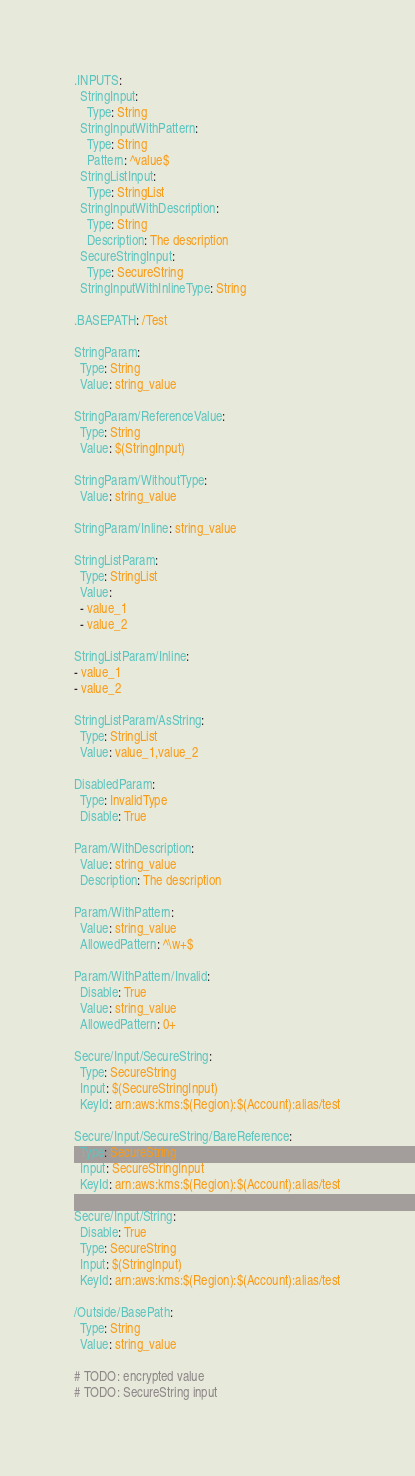Convert code to text. <code><loc_0><loc_0><loc_500><loc_500><_YAML_>.INPUTS:
  StringInput:
    Type: String
  StringInputWithPattern:
    Type: String
    Pattern: ^value$
  StringListInput:
    Type: StringList
  StringInputWithDescription:
    Type: String
    Description: The description
  SecureStringInput:
    Type: SecureString
  StringInputWithInlineType: String

.BASEPATH: /Test

StringParam:
  Type: String
  Value: string_value

StringParam/ReferenceValue:
  Type: String
  Value: $(StringInput)

StringParam/WithoutType:
  Value: string_value

StringParam/Inline: string_value

StringListParam:
  Type: StringList
  Value:
  - value_1
  - value_2

StringListParam/Inline:
- value_1
- value_2

StringListParam/AsString:
  Type: StringList
  Value: value_1,value_2

DisabledParam:
  Type: InvalidType
  Disable: True

Param/WithDescription:
  Value: string_value
  Description: The description

Param/WithPattern:
  Value: string_value
  AllowedPattern: ^\w+$

Param/WithPattern/Invalid:
  Disable: True
  Value: string_value
  AllowedPattern: 0+

Secure/Input/SecureString:
  Type: SecureString
  Input: $(SecureStringInput)
  KeyId: arn:aws:kms:$(Region):$(Account):alias/test

Secure/Input/SecureString/BareReference:
  Type: SecureString
  Input: SecureStringInput
  KeyId: arn:aws:kms:$(Region):$(Account):alias/test

Secure/Input/String:
  Disable: True
  Type: SecureString
  Input: $(StringInput)
  KeyId: arn:aws:kms:$(Region):$(Account):alias/test

/Outside/BasePath:
  Type: String
  Value: string_value

# TODO: encrypted value
# TODO: SecureString input</code> 